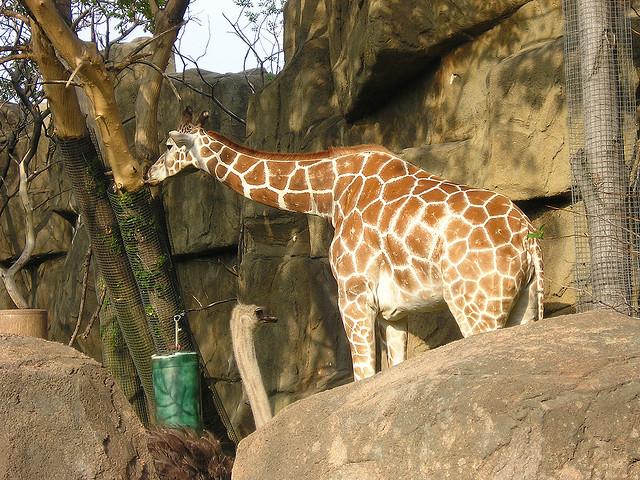Where is this animal held?
Give a very brief answer. Zoo. What is the giraffe eating?
Concise answer only. Bark. Is this a habitat?
Give a very brief answer. Yes. What kind of animal is that?
Quick response, please. Giraffe. 